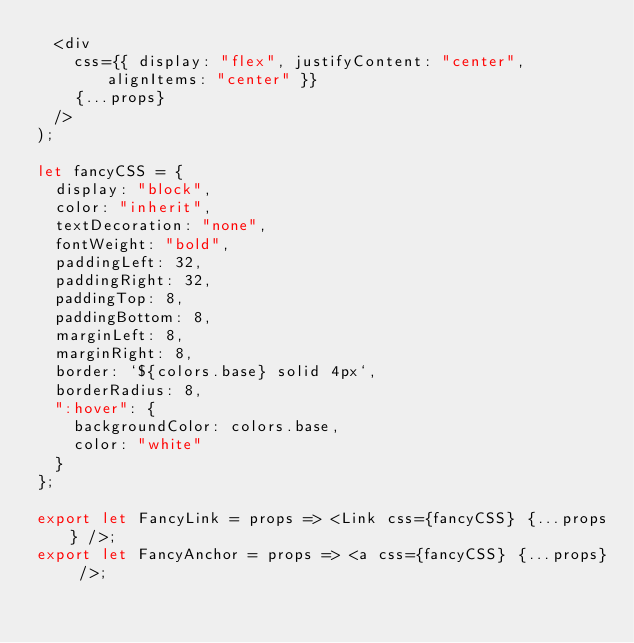<code> <loc_0><loc_0><loc_500><loc_500><_JavaScript_>  <div
    css={{ display: "flex", justifyContent: "center", alignItems: "center" }}
    {...props}
  />
);

let fancyCSS = {
  display: "block",
  color: "inherit",
  textDecoration: "none",
  fontWeight: "bold",
  paddingLeft: 32,
  paddingRight: 32,
  paddingTop: 8,
  paddingBottom: 8,
  marginLeft: 8,
  marginRight: 8,
  border: `${colors.base} solid 4px`,
  borderRadius: 8,
  ":hover": {
    backgroundColor: colors.base,
    color: "white"
  }
};

export let FancyLink = props => <Link css={fancyCSS} {...props} />;
export let FancyAnchor = props => <a css={fancyCSS} {...props} />;
</code> 